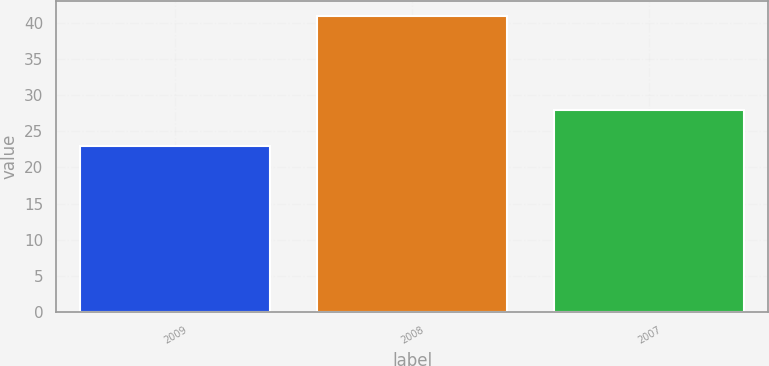Convert chart to OTSL. <chart><loc_0><loc_0><loc_500><loc_500><bar_chart><fcel>2009<fcel>2008<fcel>2007<nl><fcel>23<fcel>41<fcel>28<nl></chart> 